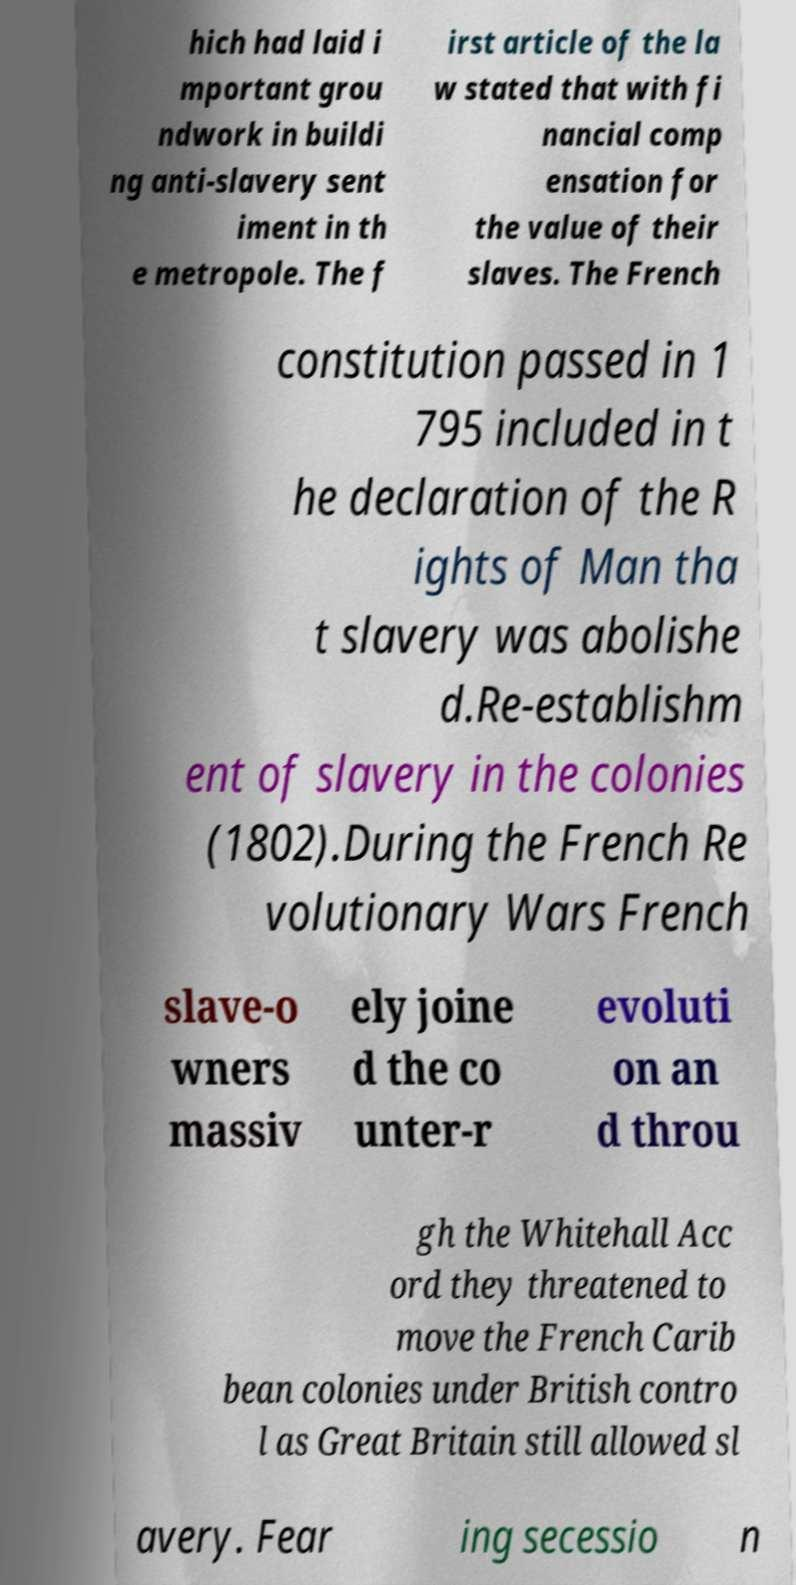I need the written content from this picture converted into text. Can you do that? hich had laid i mportant grou ndwork in buildi ng anti-slavery sent iment in th e metropole. The f irst article of the la w stated that with fi nancial comp ensation for the value of their slaves. The French constitution passed in 1 795 included in t he declaration of the R ights of Man tha t slavery was abolishe d.Re-establishm ent of slavery in the colonies (1802).During the French Re volutionary Wars French slave-o wners massiv ely joine d the co unter-r evoluti on an d throu gh the Whitehall Acc ord they threatened to move the French Carib bean colonies under British contro l as Great Britain still allowed sl avery. Fear ing secessio n 